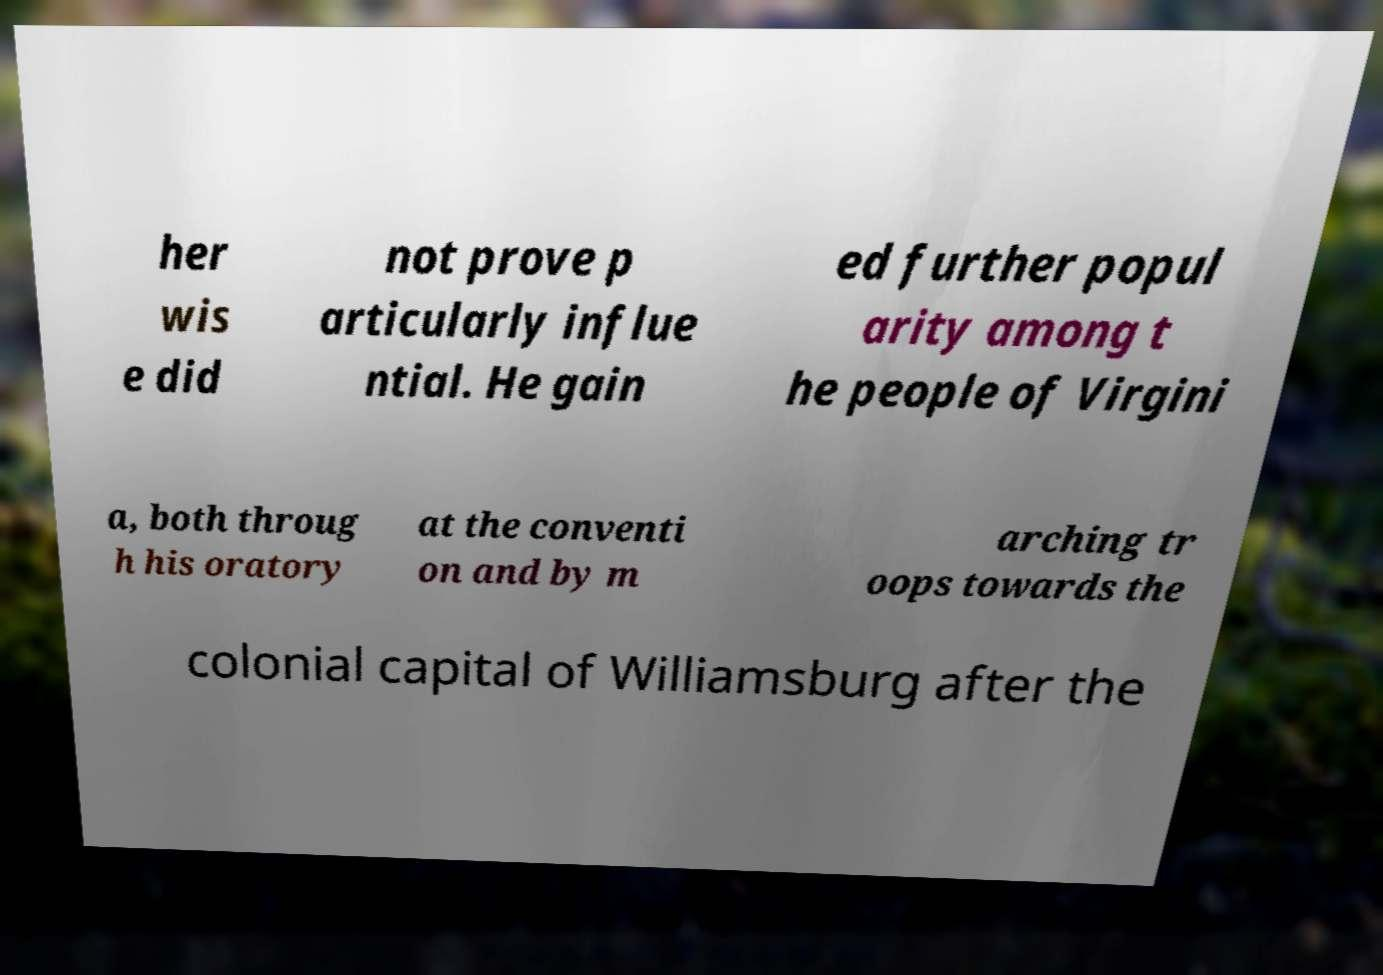Please identify and transcribe the text found in this image. her wis e did not prove p articularly influe ntial. He gain ed further popul arity among t he people of Virgini a, both throug h his oratory at the conventi on and by m arching tr oops towards the colonial capital of Williamsburg after the 